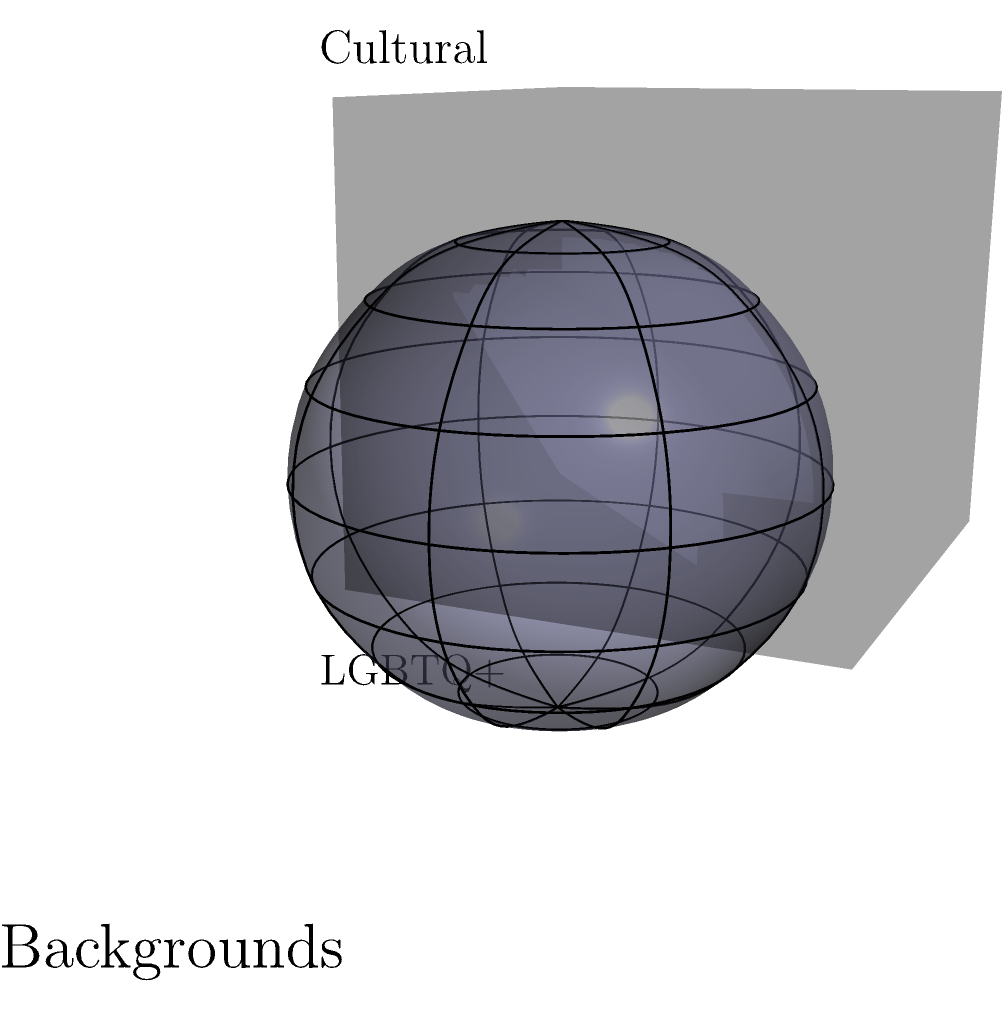Consider the topological space $X$ represented by the intersection of a sphere (representing LGBTQ+ identities) and a cube (representing cultural backgrounds) as shown in the figure. Calculate the first homology group $H_1(X)$ of this space, assuming the intersection creates a torus-like surface with two holes. To calculate the first homology group $H_1(X)$ of the given space, we'll follow these steps:

1) Observe that the intersection of the sphere and cube creates a torus-like surface with two holes. This is topologically equivalent to a 2-torus.

2) Recall the homology groups of a 2-torus $T^2$:
   $H_0(T^2) \cong \mathbb{Z}$
   $H_1(T^2) \cong \mathbb{Z} \oplus \mathbb{Z}$
   $H_2(T^2) \cong \mathbb{Z}$
   $H_n(T^2) \cong 0$ for $n > 2$

3) Since our space $X$ is homeomorphic to a 2-torus, it will have the same homology groups.

4) Therefore, the first homology group $H_1(X)$ is isomorphic to $\mathbb{Z} \oplus \mathbb{Z}$.

5) This result reflects the two independent cycles in the torus-like surface, which can be interpreted as the intersectionality of LGBTQ+ identities and cultural backgrounds.
Answer: $H_1(X) \cong \mathbb{Z} \oplus \mathbb{Z}$ 